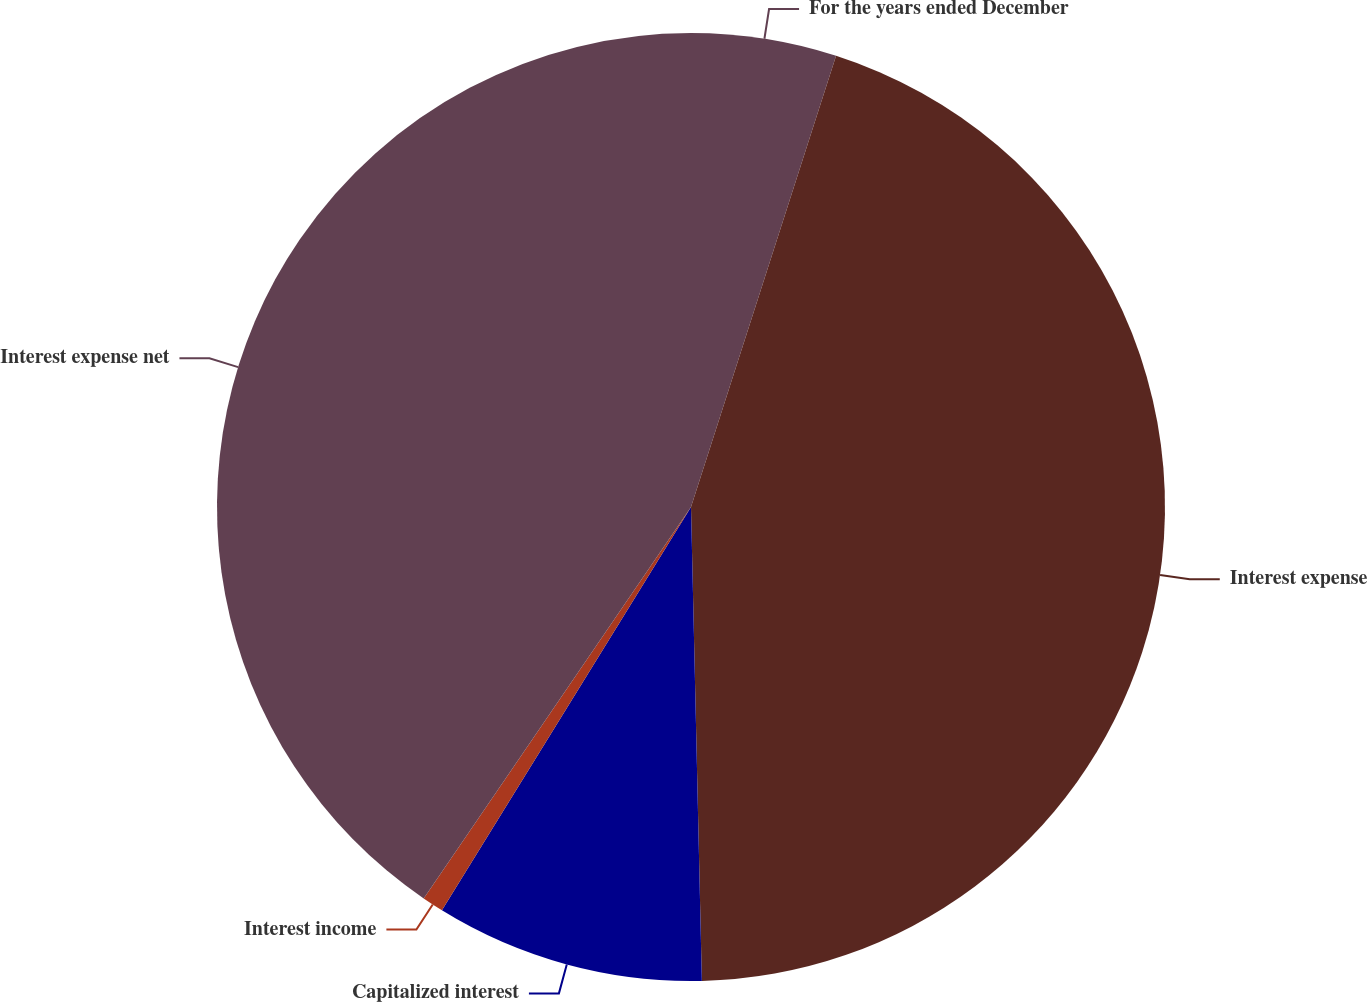<chart> <loc_0><loc_0><loc_500><loc_500><pie_chart><fcel>For the years ended December<fcel>Interest expense<fcel>Capitalized interest<fcel>Interest income<fcel>Interest expense net<nl><fcel>4.95%<fcel>44.68%<fcel>9.17%<fcel>0.73%<fcel>40.46%<nl></chart> 